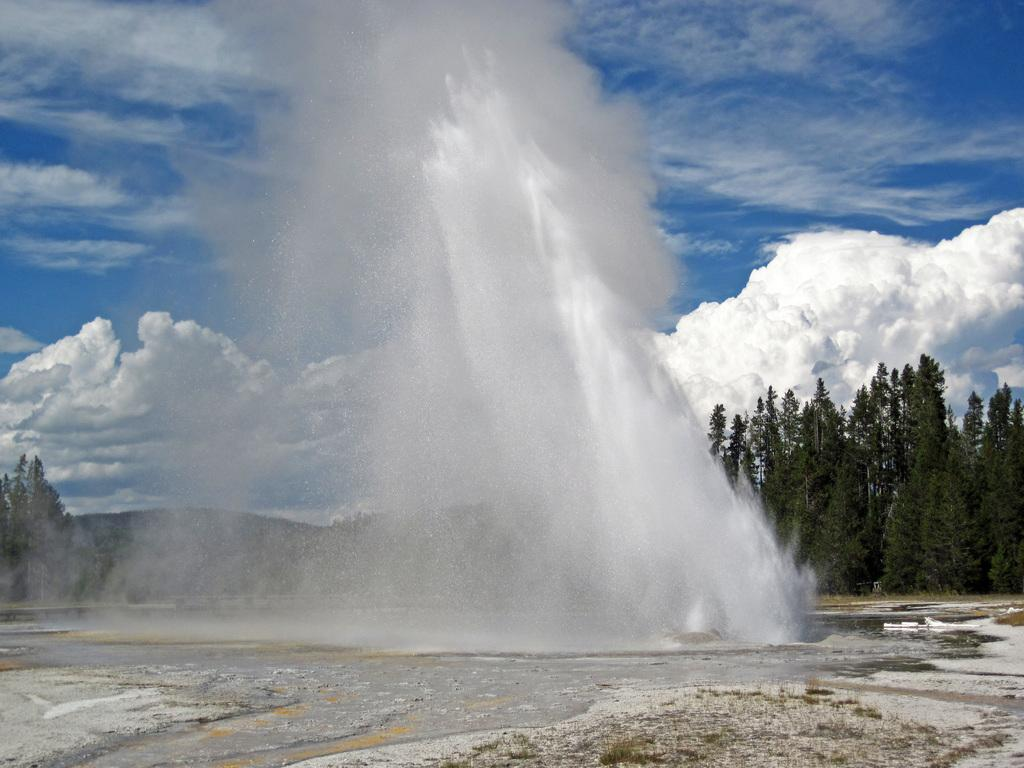What is present at the bottom of the image? There is water and a snow surface at the bottom of the image. What can be seen in the background of the image? There are trees, snowfall, and clouds in the blue sky in the background of the image. What type of music can be heard playing in the background of the image? There is no music present in the image, as it is a visual representation and does not include audio. Can you see a bucket in the image? There is no bucket present in the image. 